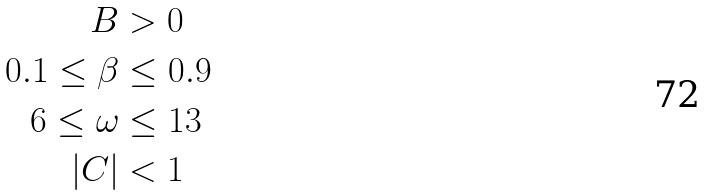Convert formula to latex. <formula><loc_0><loc_0><loc_500><loc_500>B & > 0 \\ 0 . 1 \leq \beta & \leq 0 . 9 \\ 6 \leq \omega & \leq 1 3 \\ | C | & < 1</formula> 